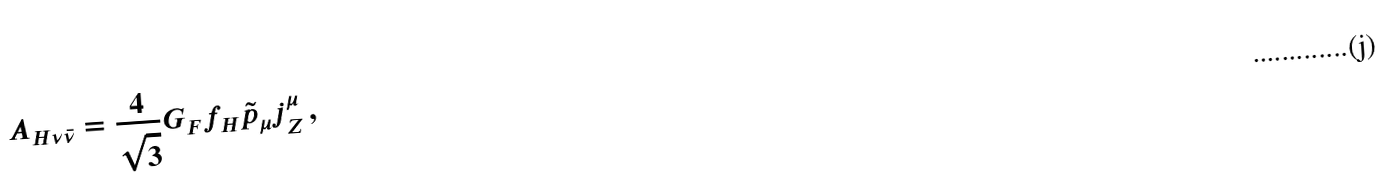<formula> <loc_0><loc_0><loc_500><loc_500>A _ { H \nu \bar { \nu } } = \frac { 4 } { \sqrt { 3 } } G _ { F } f _ { H } \tilde { p } _ { \mu } j _ { Z } ^ { \mu } \, ,</formula> 